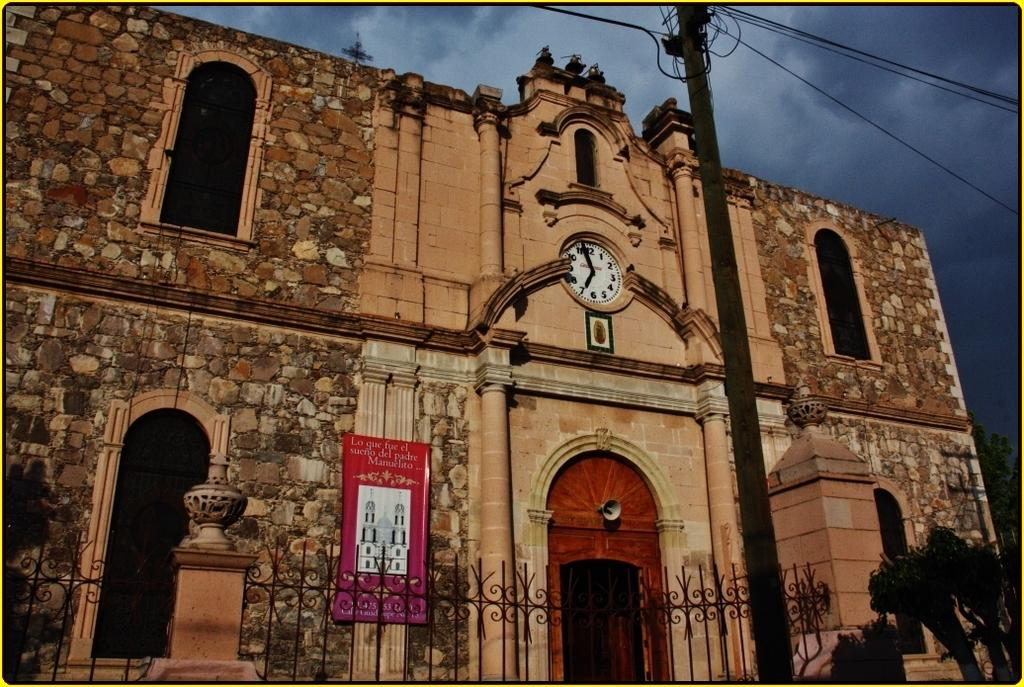<image>
Write a terse but informative summary of the picture. A banner that says "lo que fue el sueno del padre Manuelito" hangs on a church. 